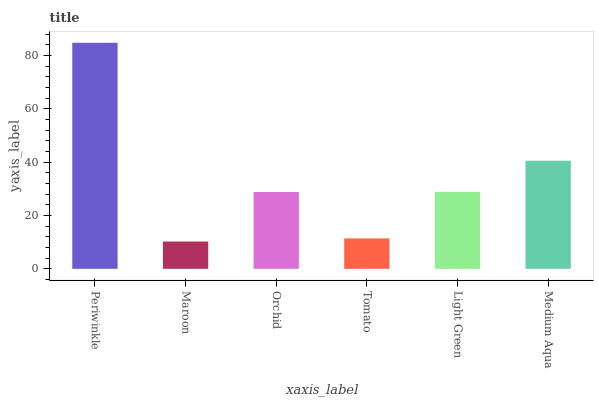Is Orchid the minimum?
Answer yes or no. No. Is Orchid the maximum?
Answer yes or no. No. Is Orchid greater than Maroon?
Answer yes or no. Yes. Is Maroon less than Orchid?
Answer yes or no. Yes. Is Maroon greater than Orchid?
Answer yes or no. No. Is Orchid less than Maroon?
Answer yes or no. No. Is Light Green the high median?
Answer yes or no. Yes. Is Orchid the low median?
Answer yes or no. Yes. Is Periwinkle the high median?
Answer yes or no. No. Is Tomato the low median?
Answer yes or no. No. 